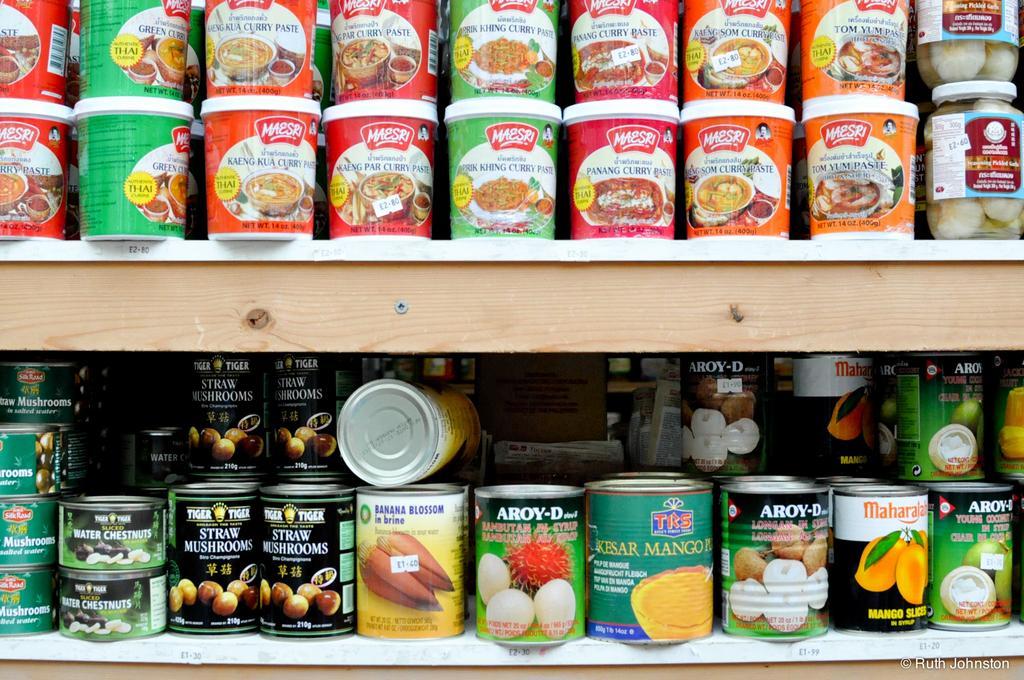How would you summarize this image in a sentence or two? In this image there there are two wooden shelf on which we can see there are so many food can tins. 